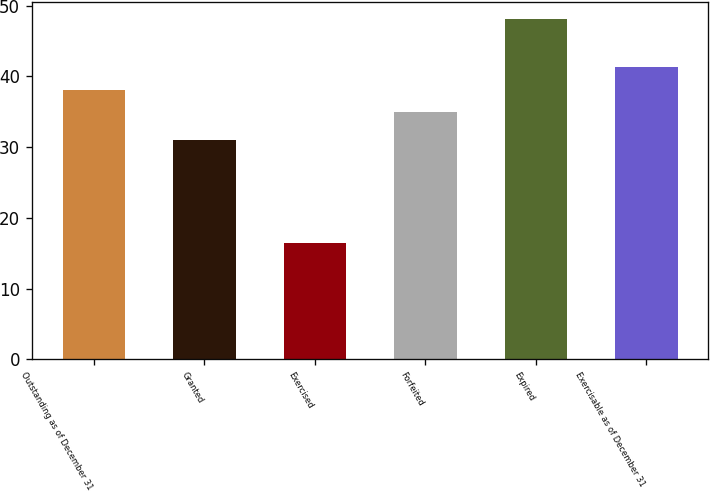Convert chart to OTSL. <chart><loc_0><loc_0><loc_500><loc_500><bar_chart><fcel>Outstanding as of December 31<fcel>Granted<fcel>Exercised<fcel>Forfeited<fcel>Expired<fcel>Exercisable as of December 31<nl><fcel>38.13<fcel>31<fcel>16.48<fcel>34.96<fcel>48.15<fcel>41.3<nl></chart> 